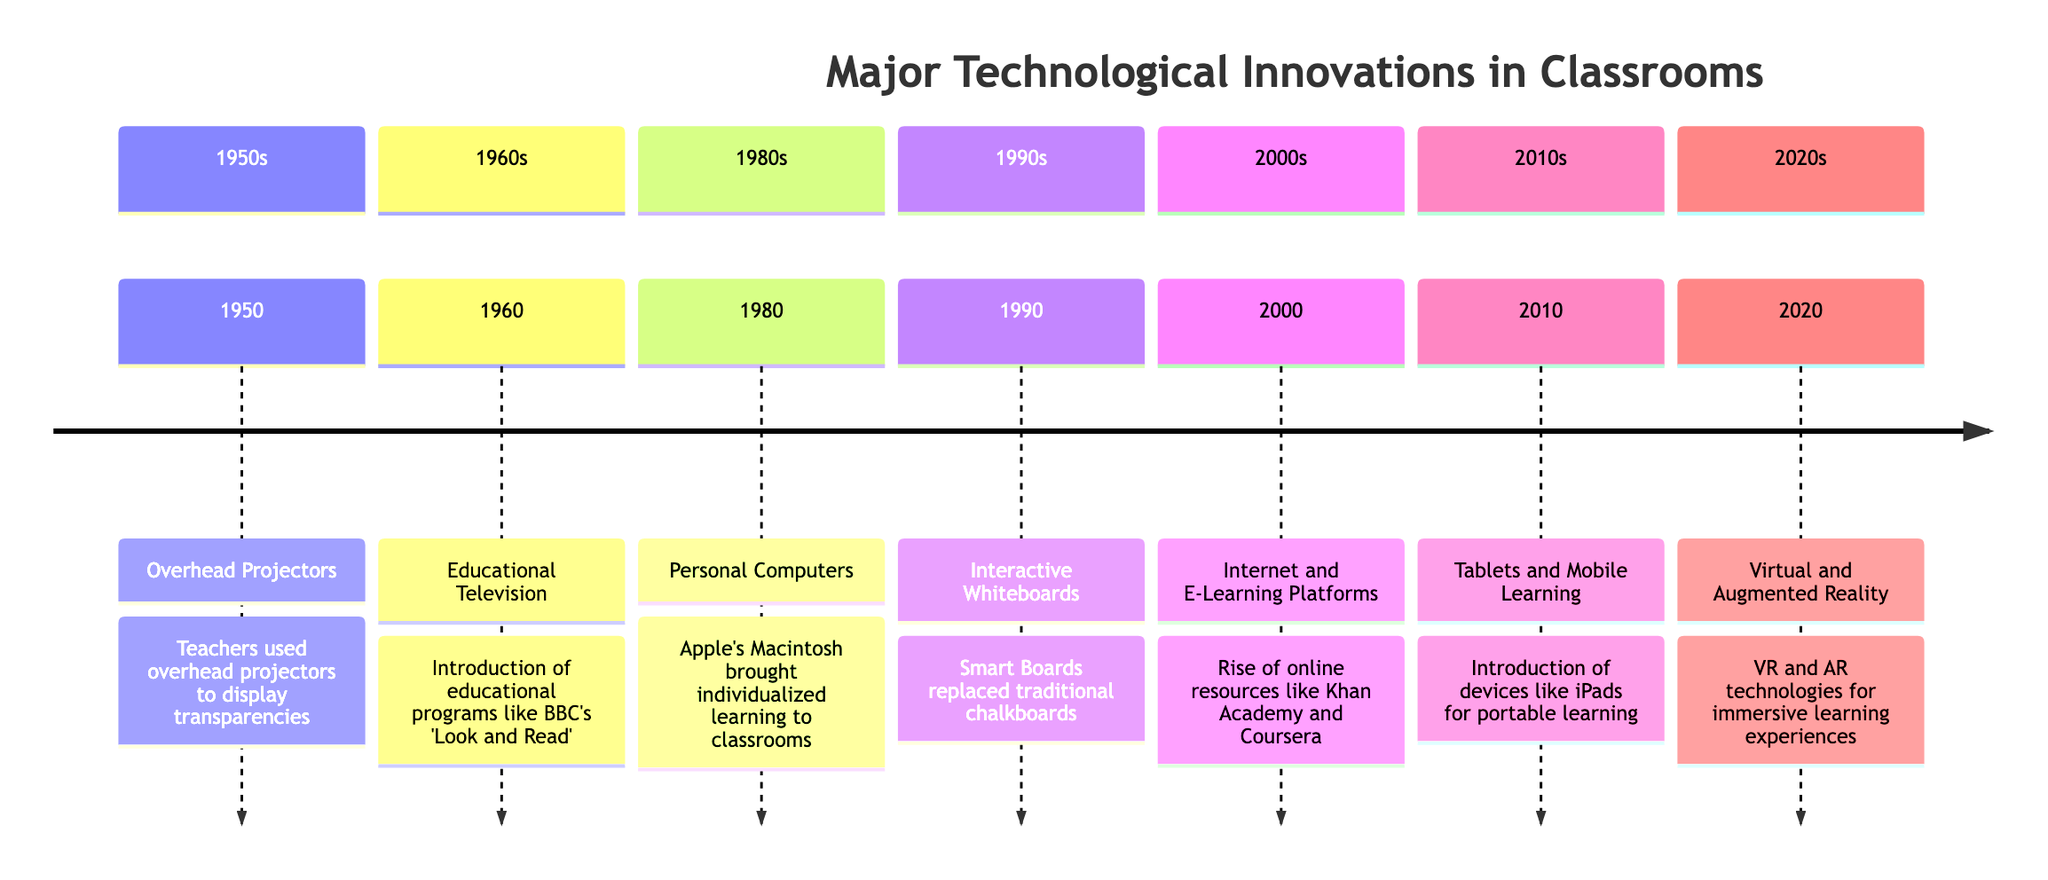What innovation was introduced in 1950? The diagram indicates that the innovation introduced in 1950 was "Overhead Projectors". This information is directly stated in the timeline for that year.
Answer: Overhead Projectors How many major technological innovations are listed? Counting the events in the diagram, there are seven major technological innovations listed. This requires a simple tally of the innovations mentioned across the years.
Answer: 7 What year saw the introduction of Educational Television? By examining the timeline, it is clear that Educational Television was introduced in 1960. This information is specifically annotated next to that innovation's description.
Answer: 1960 Which innovation comes after Personal Computers? Looking at the timeline, Personal Computers were introduced in 1980, and the next innovation listed occurs in 1990, which is Interactive Whiteboards. This requires identifying the sequence of events.
Answer: Interactive Whiteboards What type of technologies were introduced in 2020? The timeline indicates that Virtual and Augmented Reality technologies were introduced in 2020. This question requires checking the event listed for that year.
Answer: Virtual and Augmented Reality What marked the beginning of the Internet and E-Learning Platforms? According to the diagram, the year 2000 marks the introduction of Internet and E-Learning Platforms. Identifying the year corresponding to this innovation answers the question.
Answer: 2000 Identify two devices that facilitated portable learning. The timeline mentions both "Tablets" and "Mobile Learning" associated with the introduction of iPads in 2010. This question asks for a specific comparison of innovations.
Answer: Tablets and Mobile Learning How did the introduction of Interactive Whiteboards enhance learning? The description for Interactive Whiteboards states that they allowed interactive lessons with touch capability and digital integration. This requires understanding the significance of the innovation described.
Answer: Interactive lessons with touch capability and digital integration What was the innovation before Interactive Whiteboards in the timeline? Reviewing the timeline, the innovation before Interactive Whiteboards introduced in 1990 is "Personal Computers" from 1980. This involves moving back one entry in the timeline.
Answer: Personal Computers 